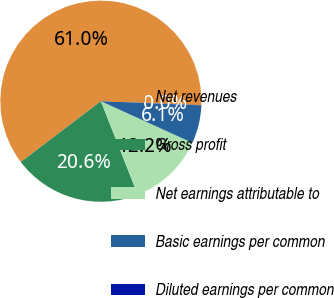<chart> <loc_0><loc_0><loc_500><loc_500><pie_chart><fcel>Net revenues<fcel>Gross profit<fcel>Net earnings attributable to<fcel>Basic earnings per common<fcel>Diluted earnings per common<nl><fcel>60.96%<fcel>20.64%<fcel>12.22%<fcel>6.13%<fcel>0.04%<nl></chart> 